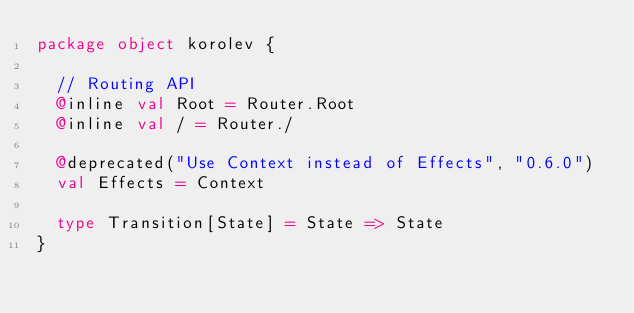Convert code to text. <code><loc_0><loc_0><loc_500><loc_500><_Scala_>package object korolev {

  // Routing API
  @inline val Root = Router.Root
  @inline val / = Router./

  @deprecated("Use Context instead of Effects", "0.6.0")
  val Effects = Context

  type Transition[State] = State => State
}
</code> 